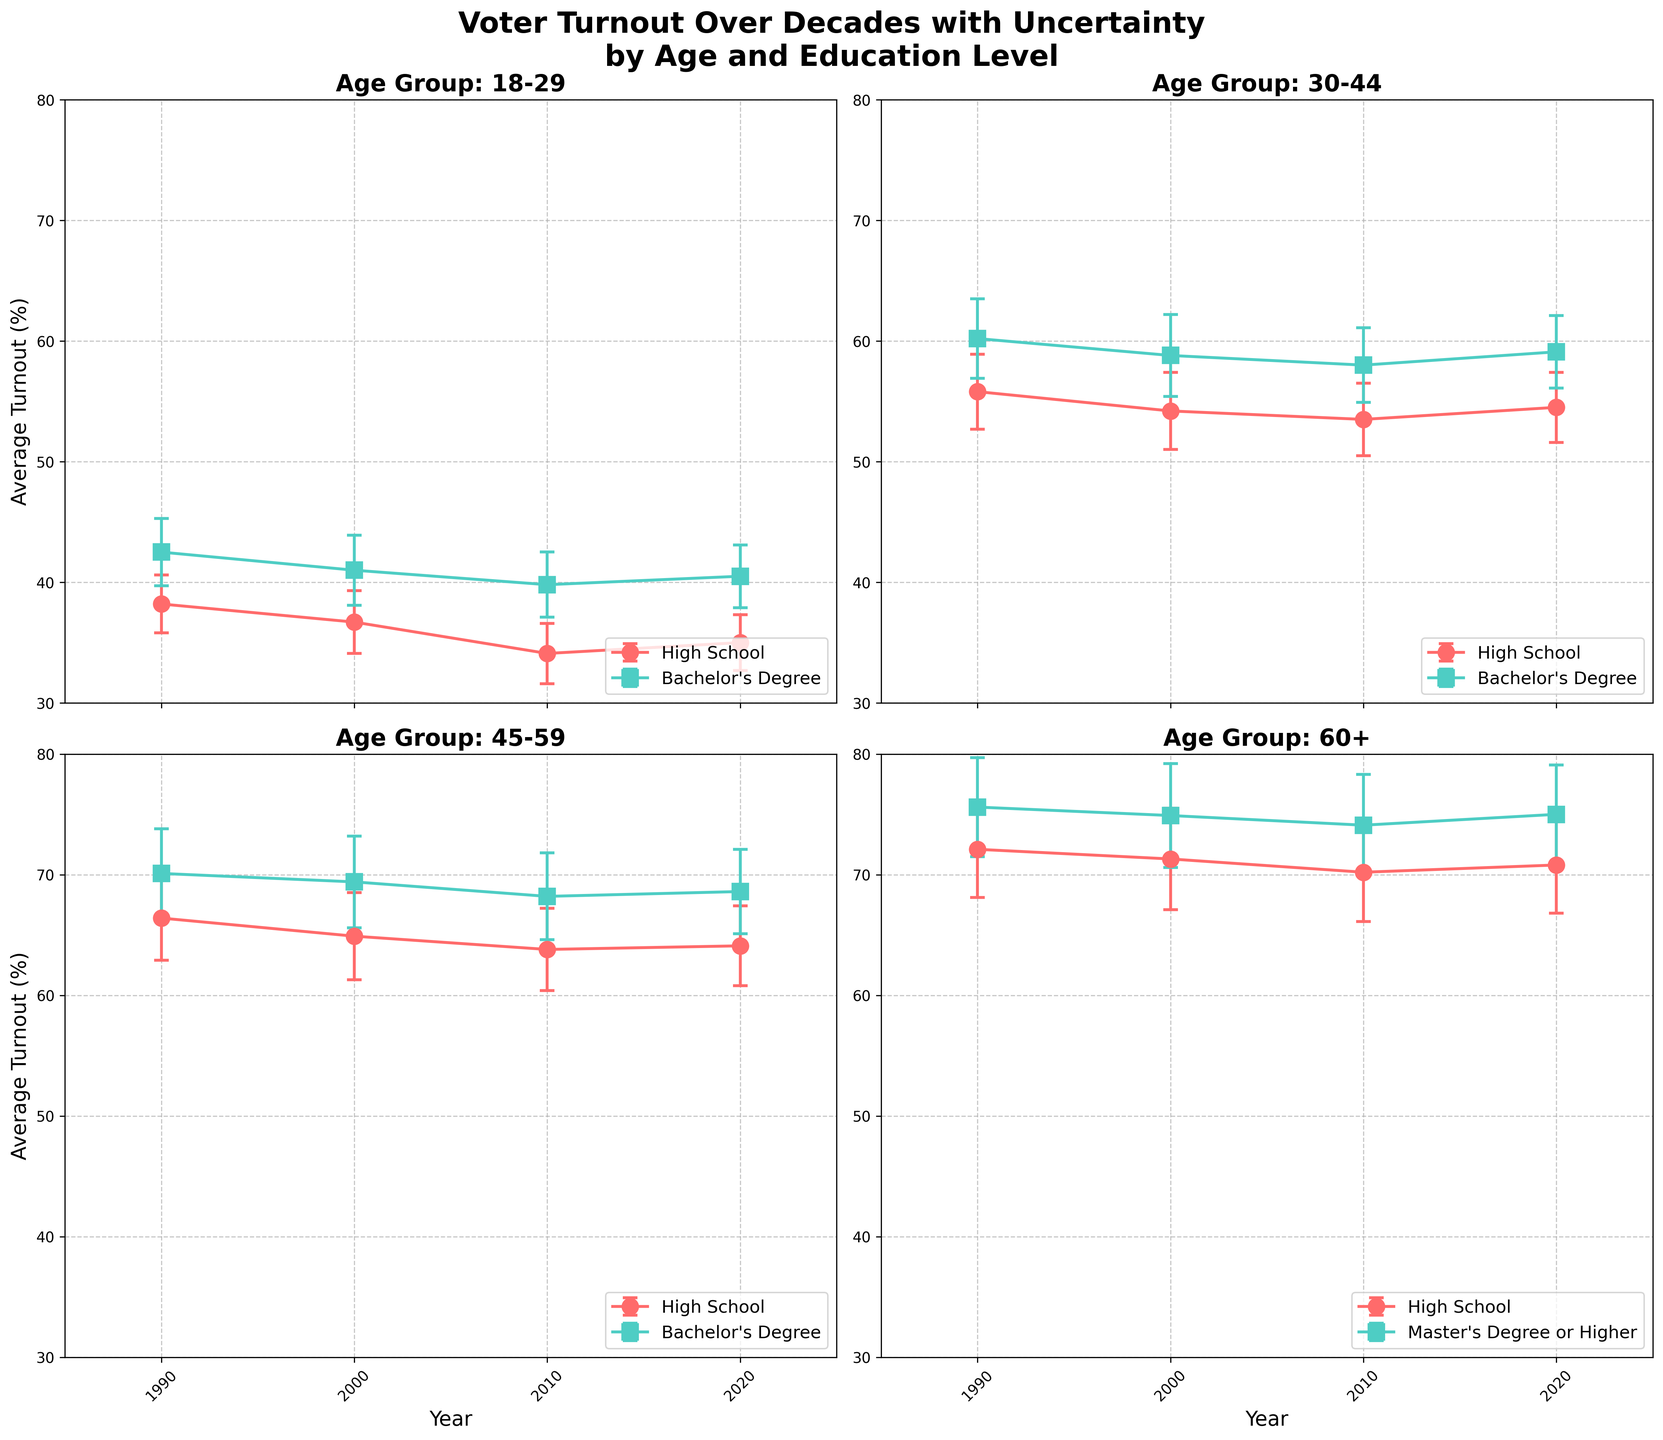what is the average voter turnout for the age group 30-44 with a bachelor's degree in 2010? The plot for the age group 30-44 shows a line for each education level. To find the average turnout for the bachelor's degree, check the marker and read the average value in 2010.
Answer: 58.0% which age group has the highest voter turnout in 2000? Look at each subplot for the year 2000 and compare the highest points with error bars for each age group. Identify the one with the largest value.
Answer: 60+ what is the difference in voter turnout between those with a high school education and a master's degree or higher in the 60+ age group in 2020? Check the subplot for the 60+ age group in 2020, note the average turnout for both education levels, and subtract the high school turnout from the master's degree or higher turnout.
Answer: 4.2% how has the voter turnout for the 18-29 age group with a high school education changed from 1990 to 2020? Look at the subplot for the 18-29 age group and compare the turnout values for the high school education line in 1990 and 2020.
Answer: Decreased by 3.2% which education level shows the most fluctuation in voter turnout for the 45-59 age group across all years? In the subplot for the 45-59 age group, compare the error bars' sizes for each education level line. The one with the largest variations represents the most fluctuation.
Answer: Bachelor's Degree what is the average voter turnout for all education levels in the age group 30-44 in 2000? Find the turnout values for each education level in the 30-44 age group subplot for the year 2000, sum them, and divide by the number of education levels. (54.2 + 58.8) / 2
Answer: 56.5% which age group shows the most significant overall increase in voter turnout with a bachelor's degree from 1990 to 2020? Look at each subplot, track the bachelor's degree turnout from 1990 to 2020, calculate the changes, and find the one with the largest increase.
Answer: 30-44 in which year did the age group 45-59 with a high school education have the lowest voter turnout? Refer to the subplot for the 45-59 age group, follow the high school education line, and identify the year with the lowest turnout value.
Answer: 2010 